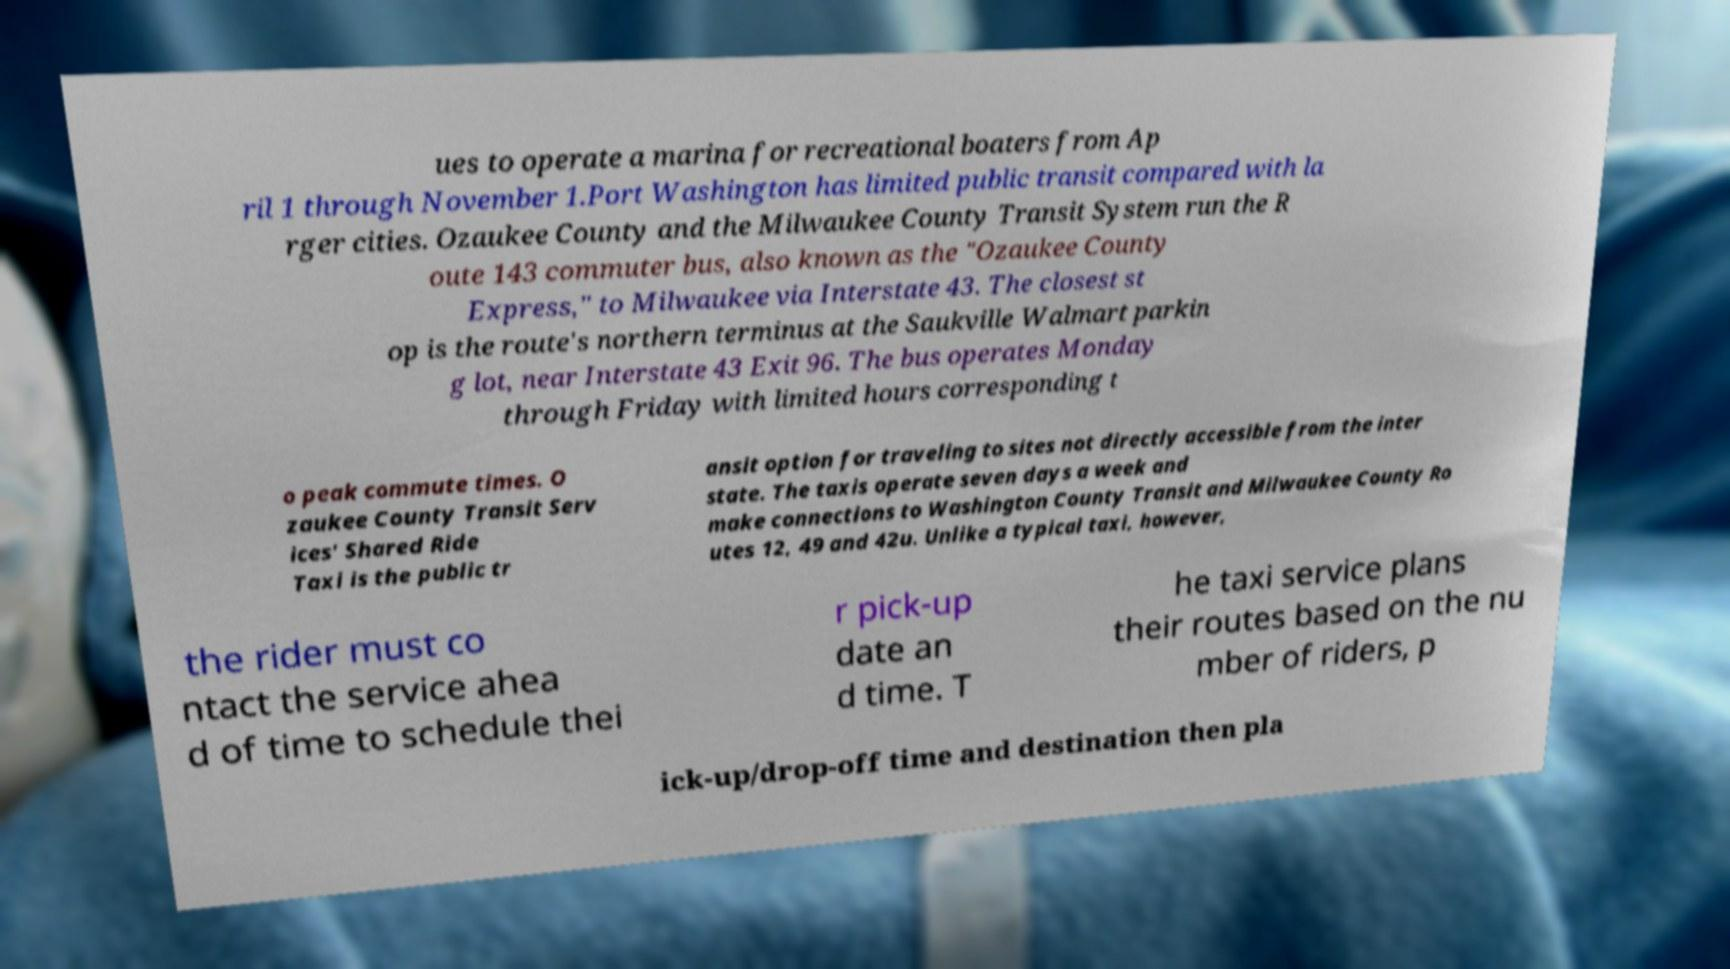Can you accurately transcribe the text from the provided image for me? ues to operate a marina for recreational boaters from Ap ril 1 through November 1.Port Washington has limited public transit compared with la rger cities. Ozaukee County and the Milwaukee County Transit System run the R oute 143 commuter bus, also known as the "Ozaukee County Express," to Milwaukee via Interstate 43. The closest st op is the route's northern terminus at the Saukville Walmart parkin g lot, near Interstate 43 Exit 96. The bus operates Monday through Friday with limited hours corresponding t o peak commute times. O zaukee County Transit Serv ices' Shared Ride Taxi is the public tr ansit option for traveling to sites not directly accessible from the inter state. The taxis operate seven days a week and make connections to Washington County Transit and Milwaukee County Ro utes 12, 49 and 42u. Unlike a typical taxi, however, the rider must co ntact the service ahea d of time to schedule thei r pick-up date an d time. T he taxi service plans their routes based on the nu mber of riders, p ick-up/drop-off time and destination then pla 